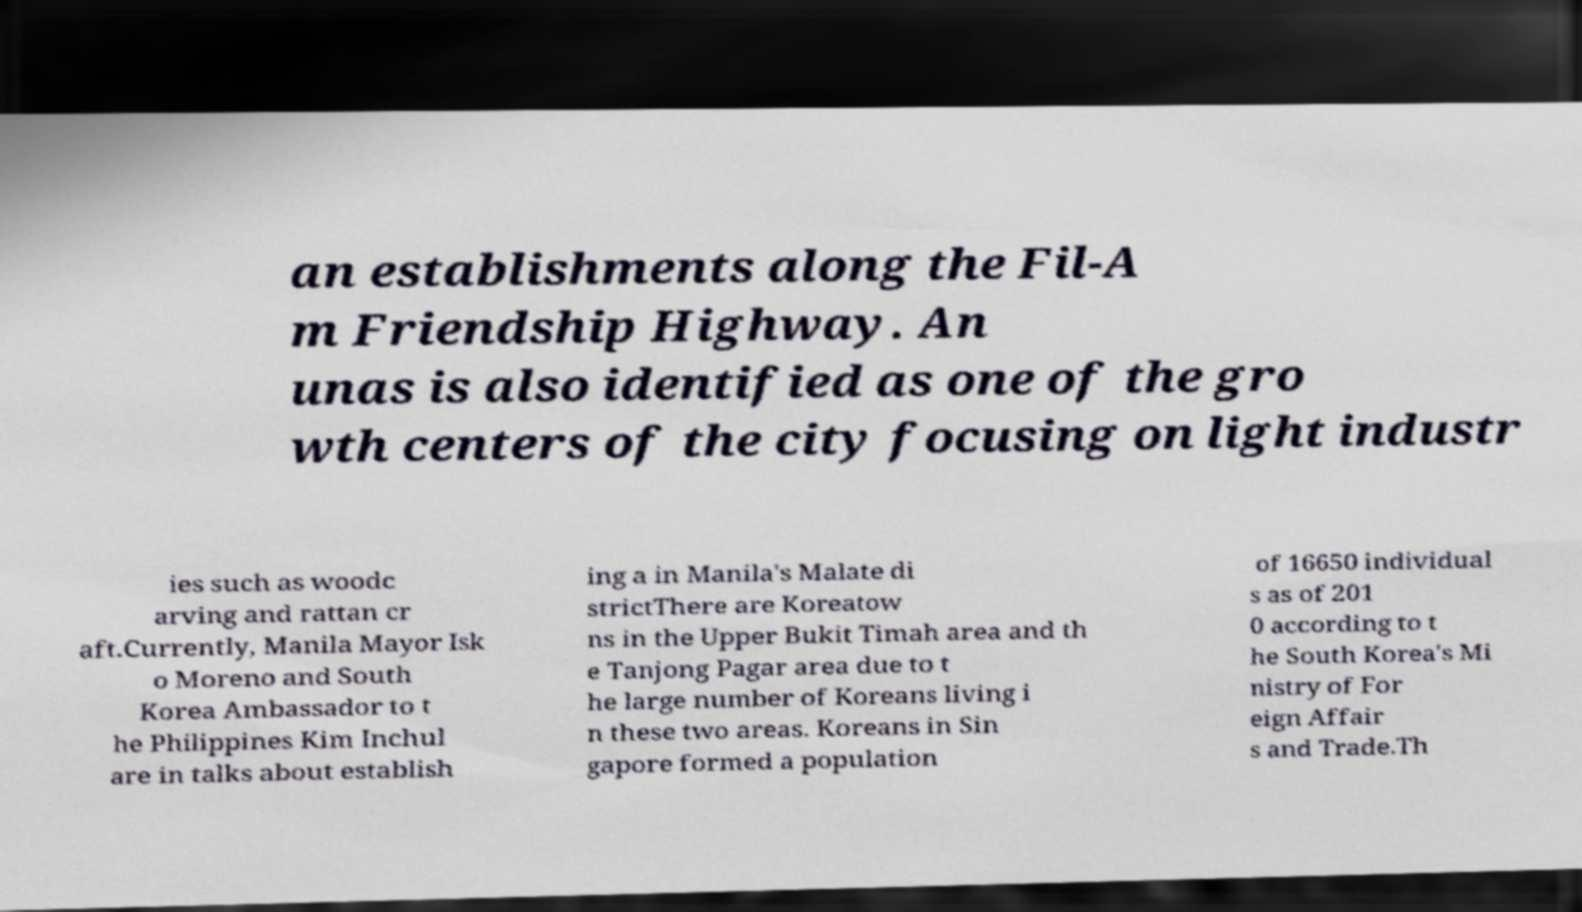What messages or text are displayed in this image? I need them in a readable, typed format. an establishments along the Fil-A m Friendship Highway. An unas is also identified as one of the gro wth centers of the city focusing on light industr ies such as woodc arving and rattan cr aft.Currently, Manila Mayor Isk o Moreno and South Korea Ambassador to t he Philippines Kim Inchul are in talks about establish ing a in Manila's Malate di strictThere are Koreatow ns in the Upper Bukit Timah area and th e Tanjong Pagar area due to t he large number of Koreans living i n these two areas. Koreans in Sin gapore formed a population of 16650 individual s as of 201 0 according to t he South Korea's Mi nistry of For eign Affair s and Trade.Th 